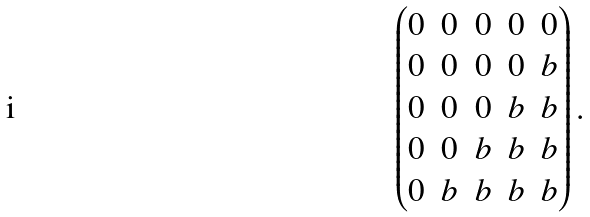<formula> <loc_0><loc_0><loc_500><loc_500>\begin{pmatrix} 0 & 0 & 0 & 0 & 0 \\ 0 & 0 & 0 & 0 & b \\ 0 & 0 & 0 & b & b \\ 0 & 0 & b & b & b \\ 0 & b & b & b & b \end{pmatrix} .</formula> 